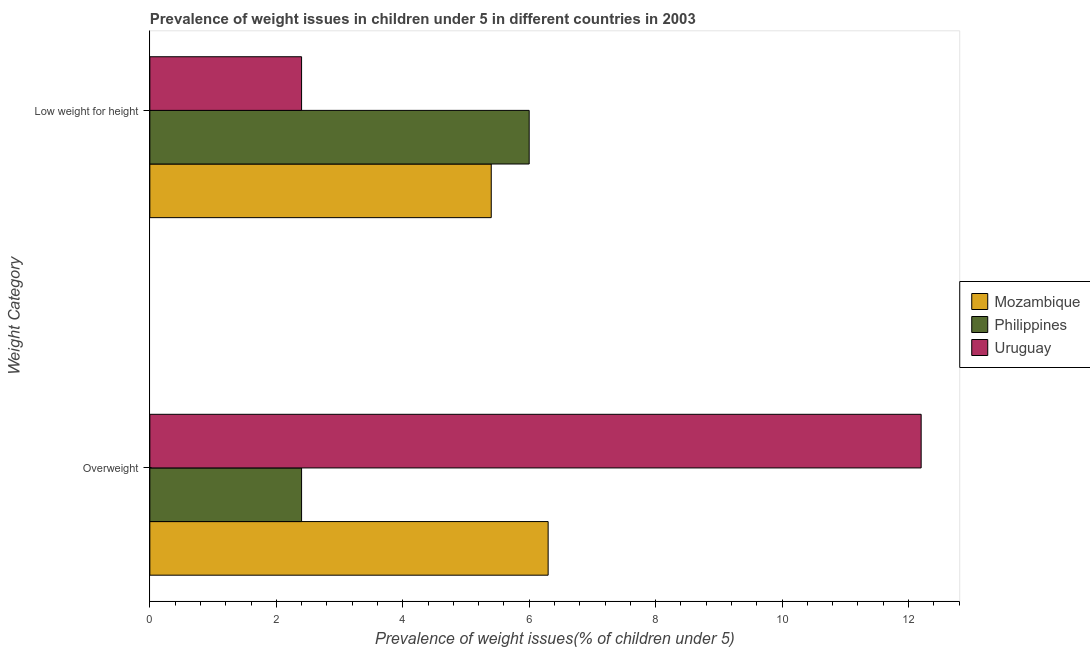Are the number of bars on each tick of the Y-axis equal?
Make the answer very short. Yes. How many bars are there on the 1st tick from the bottom?
Provide a short and direct response. 3. What is the label of the 2nd group of bars from the top?
Your answer should be very brief. Overweight. What is the percentage of underweight children in Uruguay?
Your response must be concise. 2.4. Across all countries, what is the minimum percentage of underweight children?
Offer a very short reply. 2.4. In which country was the percentage of underweight children maximum?
Provide a short and direct response. Philippines. In which country was the percentage of overweight children minimum?
Keep it short and to the point. Philippines. What is the total percentage of underweight children in the graph?
Your answer should be compact. 13.8. What is the difference between the percentage of overweight children in Mozambique and that in Philippines?
Provide a succinct answer. 3.9. What is the difference between the percentage of underweight children in Philippines and the percentage of overweight children in Uruguay?
Offer a very short reply. -6.2. What is the average percentage of underweight children per country?
Your response must be concise. 4.6. What is the difference between the percentage of underweight children and percentage of overweight children in Philippines?
Your answer should be very brief. 3.6. What is the ratio of the percentage of underweight children in Uruguay to that in Philippines?
Your answer should be very brief. 0.4. In how many countries, is the percentage of underweight children greater than the average percentage of underweight children taken over all countries?
Your answer should be compact. 2. What does the 2nd bar from the top in Low weight for height represents?
Offer a terse response. Philippines. What does the 2nd bar from the bottom in Low weight for height represents?
Ensure brevity in your answer.  Philippines. How many bars are there?
Your answer should be compact. 6. How many countries are there in the graph?
Offer a very short reply. 3. What is the difference between two consecutive major ticks on the X-axis?
Provide a succinct answer. 2. Does the graph contain any zero values?
Provide a succinct answer. No. How many legend labels are there?
Your answer should be very brief. 3. How are the legend labels stacked?
Give a very brief answer. Vertical. What is the title of the graph?
Ensure brevity in your answer.  Prevalence of weight issues in children under 5 in different countries in 2003. Does "Poland" appear as one of the legend labels in the graph?
Offer a very short reply. No. What is the label or title of the X-axis?
Your answer should be compact. Prevalence of weight issues(% of children under 5). What is the label or title of the Y-axis?
Your response must be concise. Weight Category. What is the Prevalence of weight issues(% of children under 5) of Mozambique in Overweight?
Offer a terse response. 6.3. What is the Prevalence of weight issues(% of children under 5) of Philippines in Overweight?
Make the answer very short. 2.4. What is the Prevalence of weight issues(% of children under 5) of Uruguay in Overweight?
Provide a short and direct response. 12.2. What is the Prevalence of weight issues(% of children under 5) of Mozambique in Low weight for height?
Give a very brief answer. 5.4. What is the Prevalence of weight issues(% of children under 5) in Philippines in Low weight for height?
Offer a very short reply. 6. What is the Prevalence of weight issues(% of children under 5) in Uruguay in Low weight for height?
Make the answer very short. 2.4. Across all Weight Category, what is the maximum Prevalence of weight issues(% of children under 5) of Mozambique?
Give a very brief answer. 6.3. Across all Weight Category, what is the maximum Prevalence of weight issues(% of children under 5) in Philippines?
Provide a succinct answer. 6. Across all Weight Category, what is the maximum Prevalence of weight issues(% of children under 5) of Uruguay?
Ensure brevity in your answer.  12.2. Across all Weight Category, what is the minimum Prevalence of weight issues(% of children under 5) in Mozambique?
Keep it short and to the point. 5.4. Across all Weight Category, what is the minimum Prevalence of weight issues(% of children under 5) of Philippines?
Provide a short and direct response. 2.4. Across all Weight Category, what is the minimum Prevalence of weight issues(% of children under 5) of Uruguay?
Keep it short and to the point. 2.4. What is the total Prevalence of weight issues(% of children under 5) of Mozambique in the graph?
Keep it short and to the point. 11.7. What is the total Prevalence of weight issues(% of children under 5) of Uruguay in the graph?
Keep it short and to the point. 14.6. What is the difference between the Prevalence of weight issues(% of children under 5) in Mozambique in Overweight and that in Low weight for height?
Provide a succinct answer. 0.9. What is the difference between the Prevalence of weight issues(% of children under 5) in Uruguay in Overweight and that in Low weight for height?
Keep it short and to the point. 9.8. What is the difference between the Prevalence of weight issues(% of children under 5) in Mozambique in Overweight and the Prevalence of weight issues(% of children under 5) in Philippines in Low weight for height?
Keep it short and to the point. 0.3. What is the average Prevalence of weight issues(% of children under 5) of Mozambique per Weight Category?
Your answer should be very brief. 5.85. What is the average Prevalence of weight issues(% of children under 5) of Philippines per Weight Category?
Keep it short and to the point. 4.2. What is the difference between the Prevalence of weight issues(% of children under 5) of Mozambique and Prevalence of weight issues(% of children under 5) of Philippines in Overweight?
Make the answer very short. 3.9. What is the difference between the Prevalence of weight issues(% of children under 5) in Mozambique and Prevalence of weight issues(% of children under 5) in Philippines in Low weight for height?
Keep it short and to the point. -0.6. What is the difference between the Prevalence of weight issues(% of children under 5) of Mozambique and Prevalence of weight issues(% of children under 5) of Uruguay in Low weight for height?
Keep it short and to the point. 3. What is the difference between the Prevalence of weight issues(% of children under 5) in Philippines and Prevalence of weight issues(% of children under 5) in Uruguay in Low weight for height?
Offer a terse response. 3.6. What is the ratio of the Prevalence of weight issues(% of children under 5) of Mozambique in Overweight to that in Low weight for height?
Make the answer very short. 1.17. What is the ratio of the Prevalence of weight issues(% of children under 5) of Uruguay in Overweight to that in Low weight for height?
Your answer should be very brief. 5.08. What is the difference between the highest and the second highest Prevalence of weight issues(% of children under 5) of Mozambique?
Your answer should be very brief. 0.9. What is the difference between the highest and the lowest Prevalence of weight issues(% of children under 5) in Mozambique?
Keep it short and to the point. 0.9. 